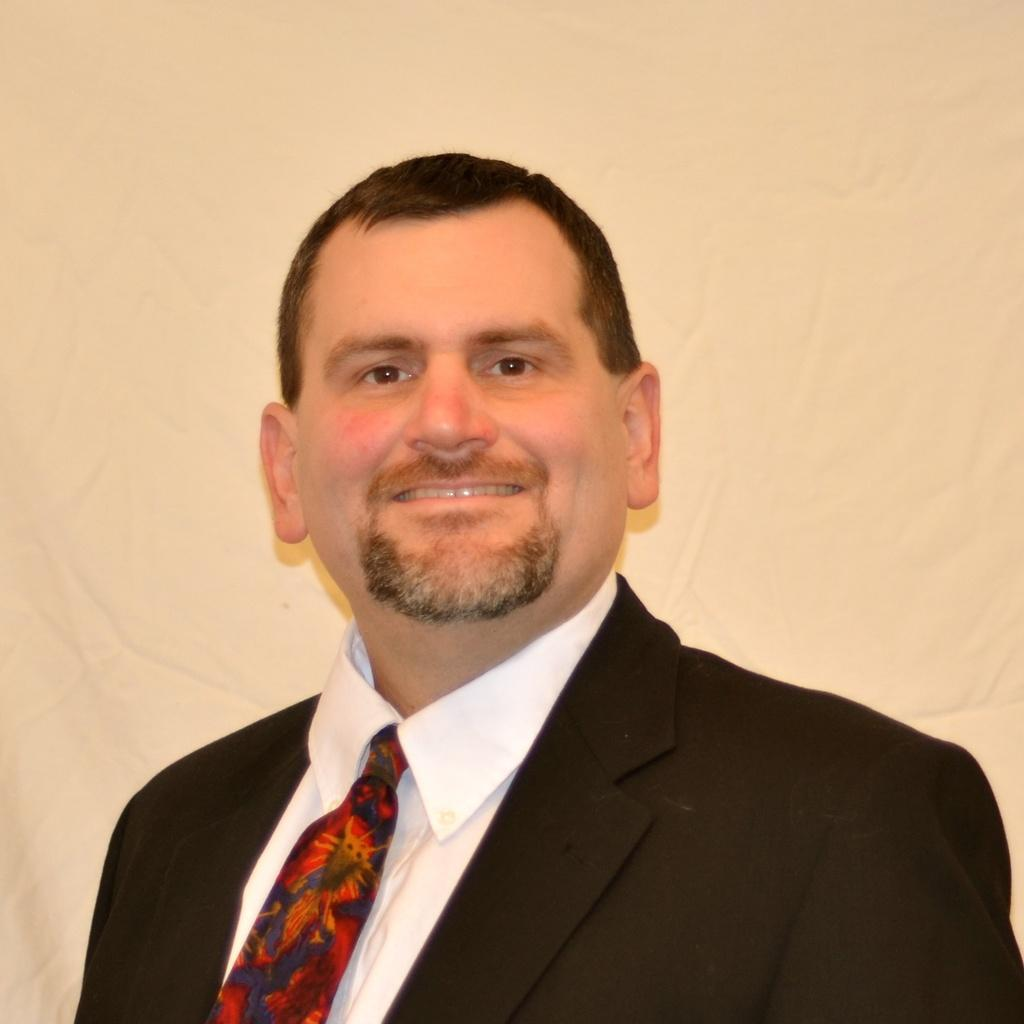Who is present in the image? There is a man in the image. What can be seen behind the man in the image? The background of the image is white. What type of store can be seen in the background of the image? There is no store present in the image; the background is white. How many stars are visible in the image? There are no stars visible in the image, as the background is white. 